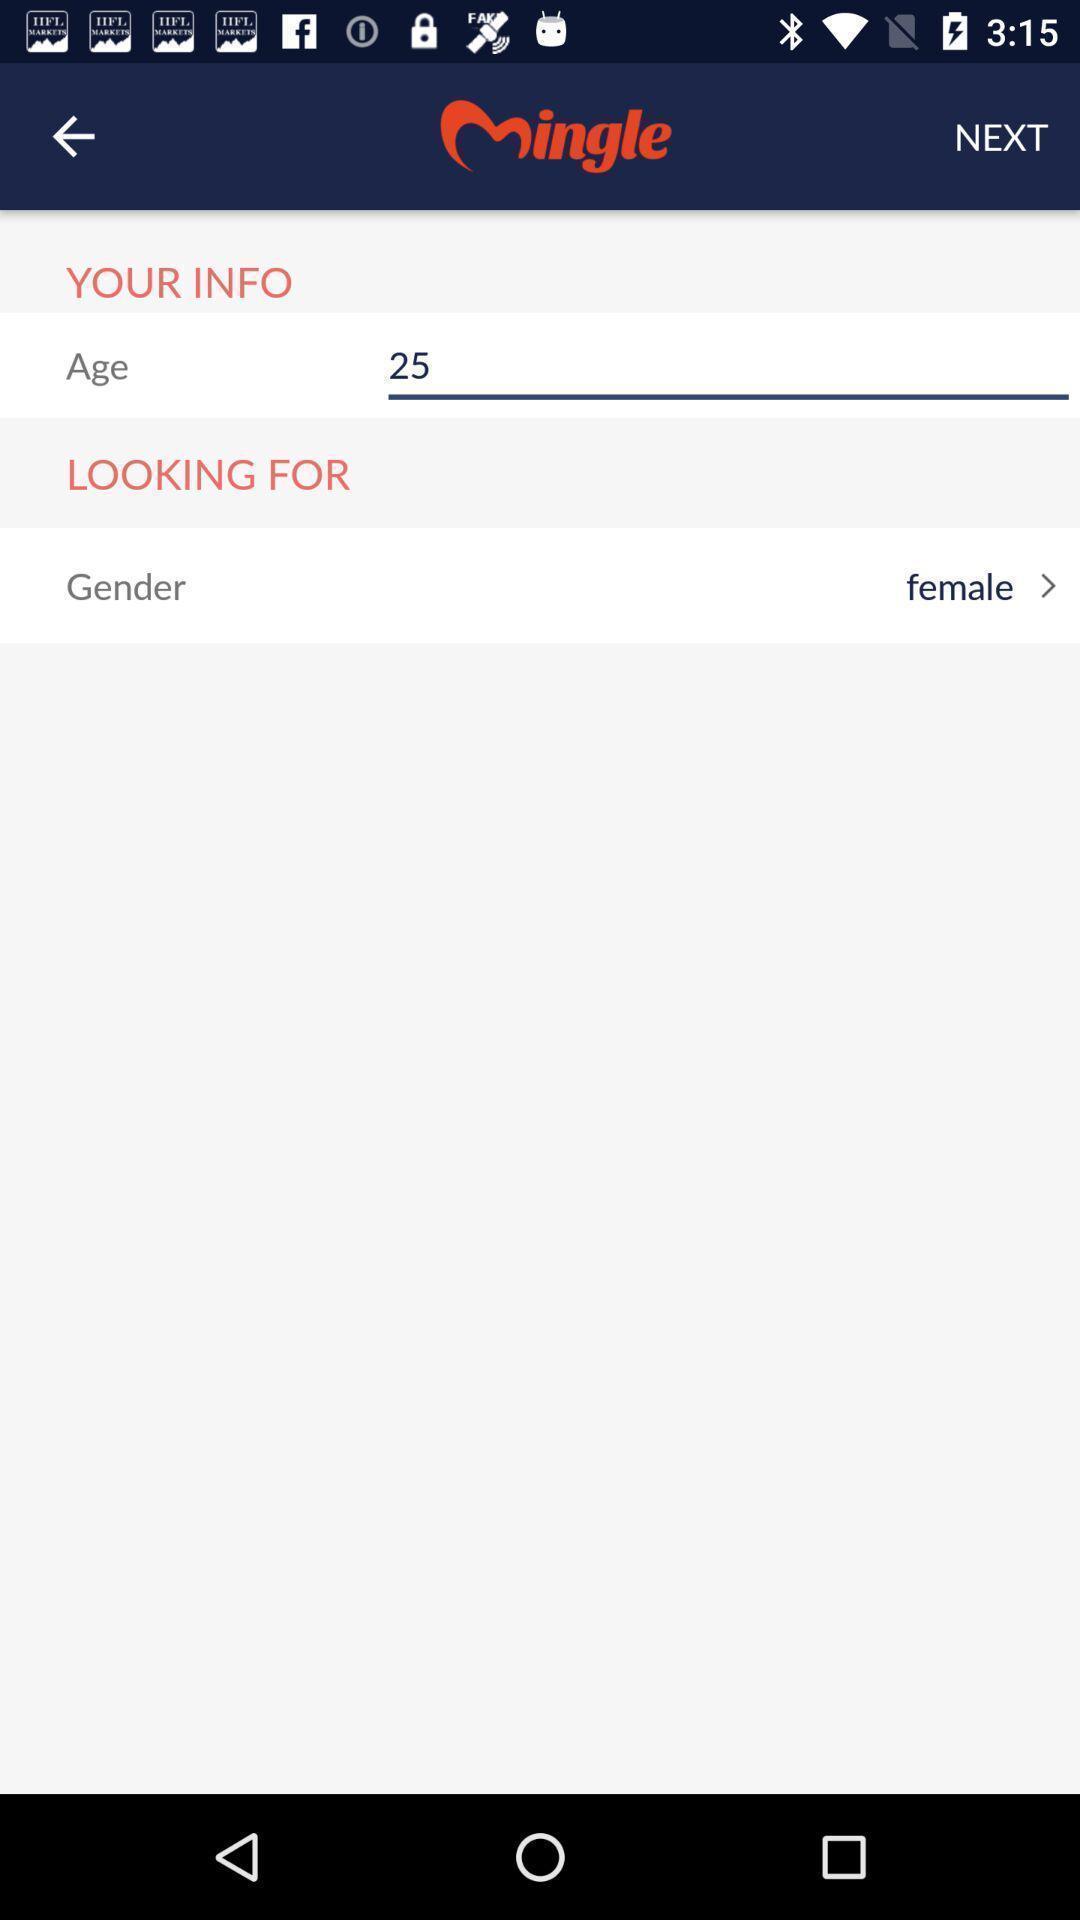Explain the elements present in this screenshot. Page displaying info to be entered in a dating app. 